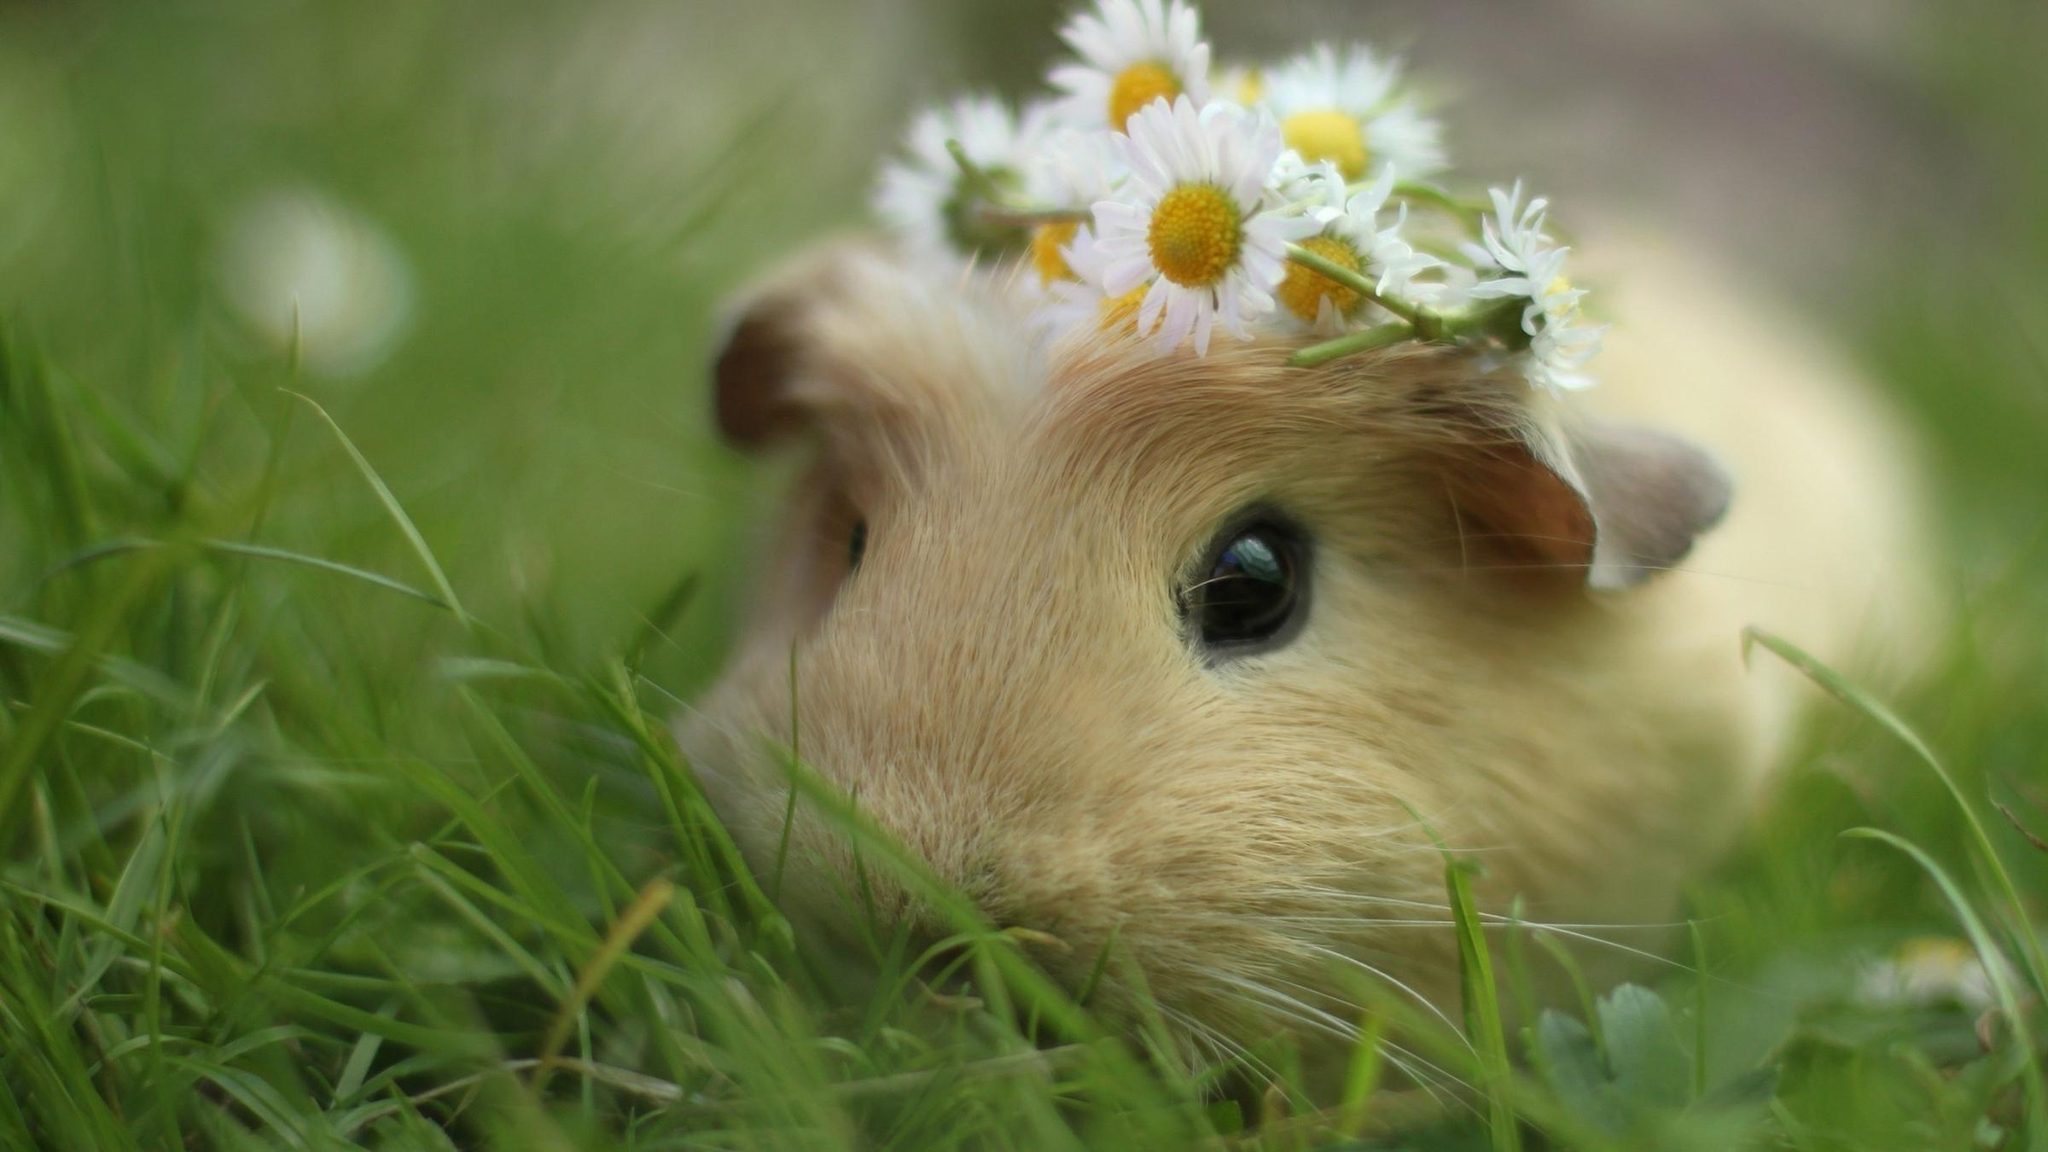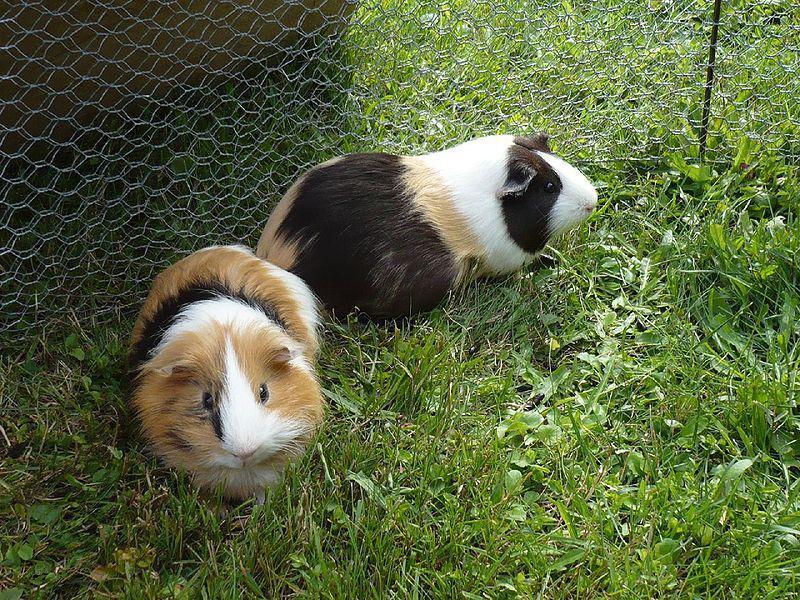The first image is the image on the left, the second image is the image on the right. Given the left and right images, does the statement "There is one animal in the image on the left." hold true? Answer yes or no. Yes. 